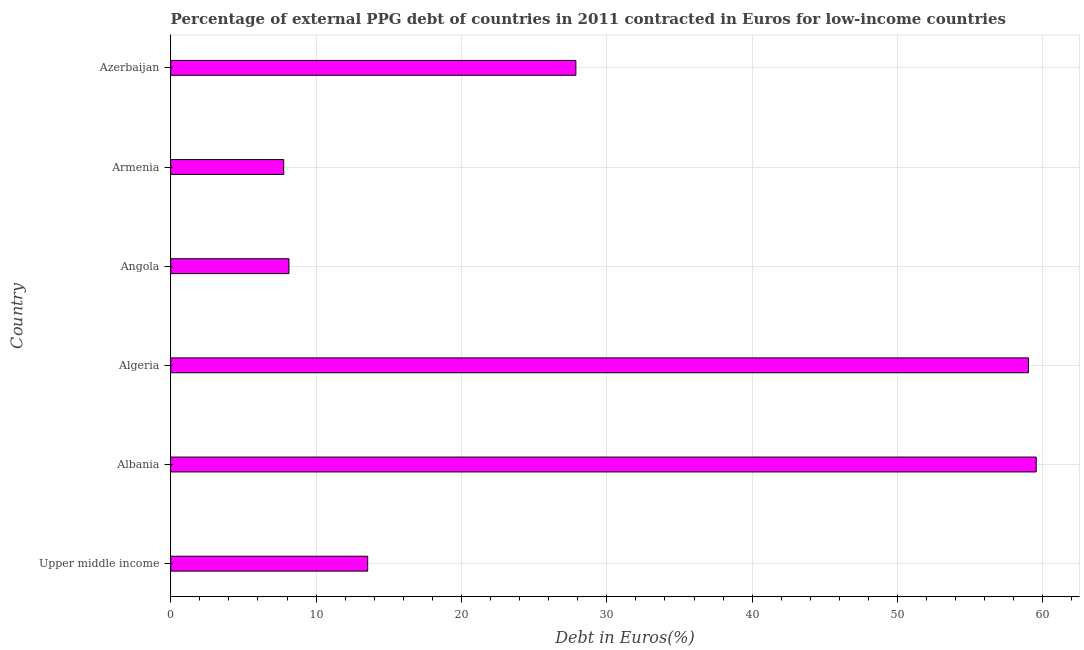What is the title of the graph?
Offer a terse response. Percentage of external PPG debt of countries in 2011 contracted in Euros for low-income countries. What is the label or title of the X-axis?
Give a very brief answer. Debt in Euros(%). What is the currency composition of ppg debt in Algeria?
Your answer should be very brief. 59.01. Across all countries, what is the maximum currency composition of ppg debt?
Your answer should be compact. 59.54. Across all countries, what is the minimum currency composition of ppg debt?
Make the answer very short. 7.77. In which country was the currency composition of ppg debt maximum?
Provide a short and direct response. Albania. In which country was the currency composition of ppg debt minimum?
Offer a terse response. Armenia. What is the sum of the currency composition of ppg debt?
Provide a short and direct response. 175.89. What is the difference between the currency composition of ppg debt in Armenia and Upper middle income?
Offer a terse response. -5.78. What is the average currency composition of ppg debt per country?
Make the answer very short. 29.31. What is the median currency composition of ppg debt?
Provide a succinct answer. 20.71. In how many countries, is the currency composition of ppg debt greater than 44 %?
Provide a short and direct response. 2. What is the ratio of the currency composition of ppg debt in Angola to that in Azerbaijan?
Ensure brevity in your answer.  0.29. What is the difference between the highest and the second highest currency composition of ppg debt?
Provide a succinct answer. 0.53. Is the sum of the currency composition of ppg debt in Algeria and Armenia greater than the maximum currency composition of ppg debt across all countries?
Provide a short and direct response. Yes. What is the difference between the highest and the lowest currency composition of ppg debt?
Your response must be concise. 51.77. How many countries are there in the graph?
Provide a succinct answer. 6. Are the values on the major ticks of X-axis written in scientific E-notation?
Offer a terse response. No. What is the Debt in Euros(%) of Upper middle income?
Offer a very short reply. 13.55. What is the Debt in Euros(%) in Albania?
Offer a terse response. 59.54. What is the Debt in Euros(%) of Algeria?
Offer a terse response. 59.01. What is the Debt in Euros(%) in Angola?
Make the answer very short. 8.13. What is the Debt in Euros(%) in Armenia?
Offer a terse response. 7.77. What is the Debt in Euros(%) of Azerbaijan?
Provide a succinct answer. 27.87. What is the difference between the Debt in Euros(%) in Upper middle income and Albania?
Give a very brief answer. -45.99. What is the difference between the Debt in Euros(%) in Upper middle income and Algeria?
Your response must be concise. -45.46. What is the difference between the Debt in Euros(%) in Upper middle income and Angola?
Provide a succinct answer. 5.42. What is the difference between the Debt in Euros(%) in Upper middle income and Armenia?
Your answer should be very brief. 5.78. What is the difference between the Debt in Euros(%) in Upper middle income and Azerbaijan?
Keep it short and to the point. -14.32. What is the difference between the Debt in Euros(%) in Albania and Algeria?
Offer a very short reply. 0.53. What is the difference between the Debt in Euros(%) in Albania and Angola?
Offer a terse response. 51.41. What is the difference between the Debt in Euros(%) in Albania and Armenia?
Your response must be concise. 51.77. What is the difference between the Debt in Euros(%) in Albania and Azerbaijan?
Keep it short and to the point. 31.67. What is the difference between the Debt in Euros(%) in Algeria and Angola?
Keep it short and to the point. 50.88. What is the difference between the Debt in Euros(%) in Algeria and Armenia?
Your answer should be very brief. 51.24. What is the difference between the Debt in Euros(%) in Algeria and Azerbaijan?
Provide a succinct answer. 31.14. What is the difference between the Debt in Euros(%) in Angola and Armenia?
Your answer should be compact. 0.36. What is the difference between the Debt in Euros(%) in Angola and Azerbaijan?
Provide a short and direct response. -19.74. What is the difference between the Debt in Euros(%) in Armenia and Azerbaijan?
Provide a succinct answer. -20.1. What is the ratio of the Debt in Euros(%) in Upper middle income to that in Albania?
Keep it short and to the point. 0.23. What is the ratio of the Debt in Euros(%) in Upper middle income to that in Algeria?
Your response must be concise. 0.23. What is the ratio of the Debt in Euros(%) in Upper middle income to that in Angola?
Give a very brief answer. 1.67. What is the ratio of the Debt in Euros(%) in Upper middle income to that in Armenia?
Make the answer very short. 1.74. What is the ratio of the Debt in Euros(%) in Upper middle income to that in Azerbaijan?
Make the answer very short. 0.49. What is the ratio of the Debt in Euros(%) in Albania to that in Algeria?
Make the answer very short. 1.01. What is the ratio of the Debt in Euros(%) in Albania to that in Angola?
Offer a terse response. 7.32. What is the ratio of the Debt in Euros(%) in Albania to that in Armenia?
Give a very brief answer. 7.66. What is the ratio of the Debt in Euros(%) in Albania to that in Azerbaijan?
Ensure brevity in your answer.  2.14. What is the ratio of the Debt in Euros(%) in Algeria to that in Angola?
Your answer should be very brief. 7.25. What is the ratio of the Debt in Euros(%) in Algeria to that in Armenia?
Ensure brevity in your answer.  7.59. What is the ratio of the Debt in Euros(%) in Algeria to that in Azerbaijan?
Your answer should be very brief. 2.12. What is the ratio of the Debt in Euros(%) in Angola to that in Armenia?
Your answer should be compact. 1.05. What is the ratio of the Debt in Euros(%) in Angola to that in Azerbaijan?
Give a very brief answer. 0.29. What is the ratio of the Debt in Euros(%) in Armenia to that in Azerbaijan?
Your answer should be very brief. 0.28. 